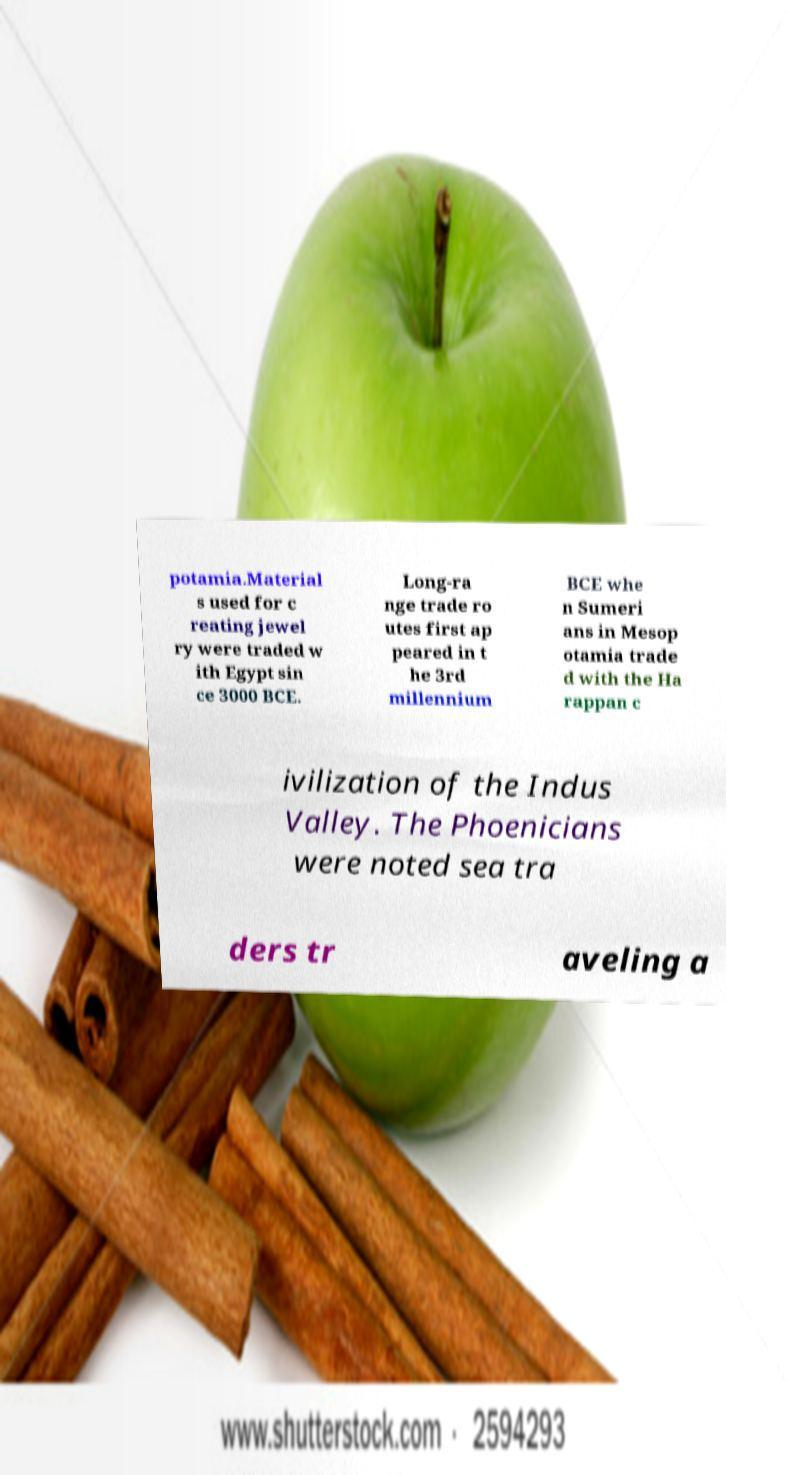What messages or text are displayed in this image? I need them in a readable, typed format. potamia.Material s used for c reating jewel ry were traded w ith Egypt sin ce 3000 BCE. Long-ra nge trade ro utes first ap peared in t he 3rd millennium BCE whe n Sumeri ans in Mesop otamia trade d with the Ha rappan c ivilization of the Indus Valley. The Phoenicians were noted sea tra ders tr aveling a 